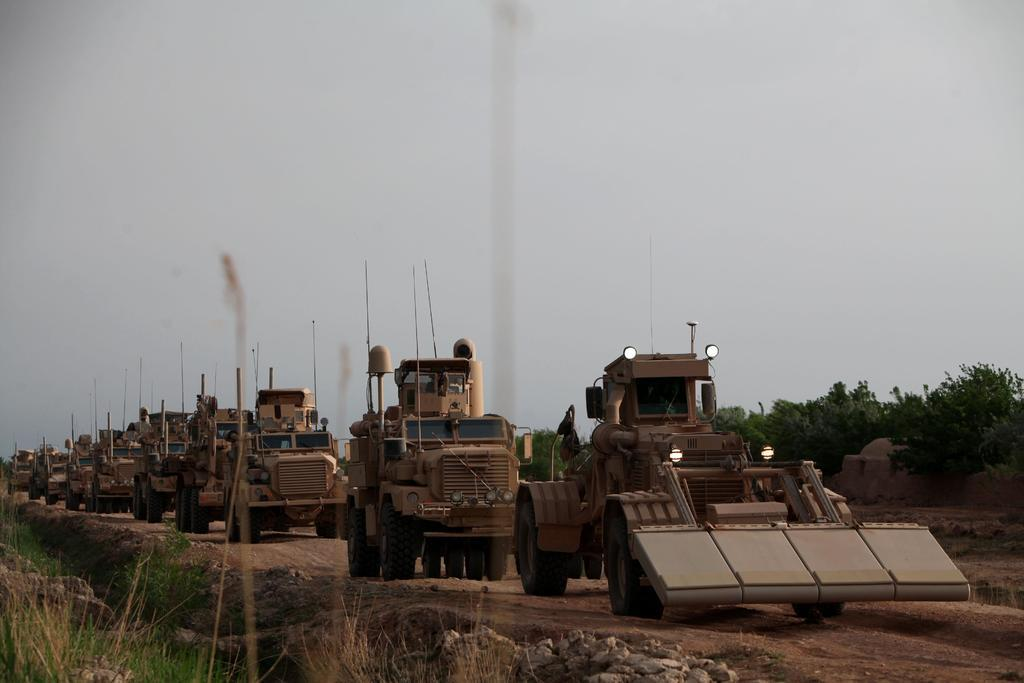What can be seen on the road in the image? There are vehicles on the road in the image. What type of vegetation is present in the image? There are trees in the right corner of the image. What type of stitch is used to create the story in the image? There is no story or stitching present in the image; it features vehicles on the road and trees in the right corner. How does the society depicted in the image function? There is no society depicted in the image, as it only shows vehicles on the road and trees in the right corner. 